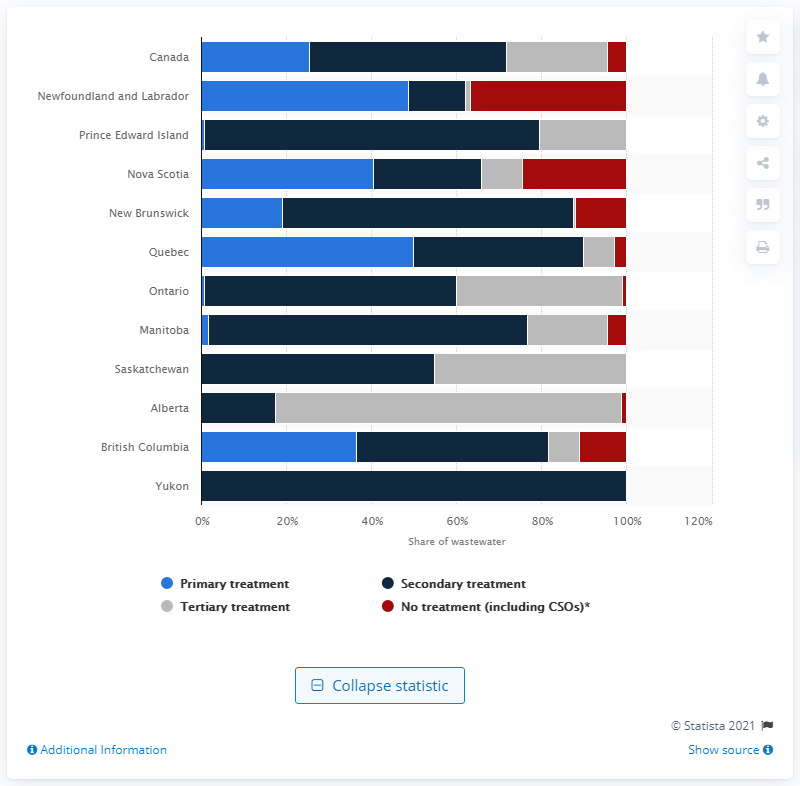Highlight a few significant elements in this photo. In 2017, approximately 36.6% of the municipal wastewater in Newfoundland and Labrador was discharged without treatment. 